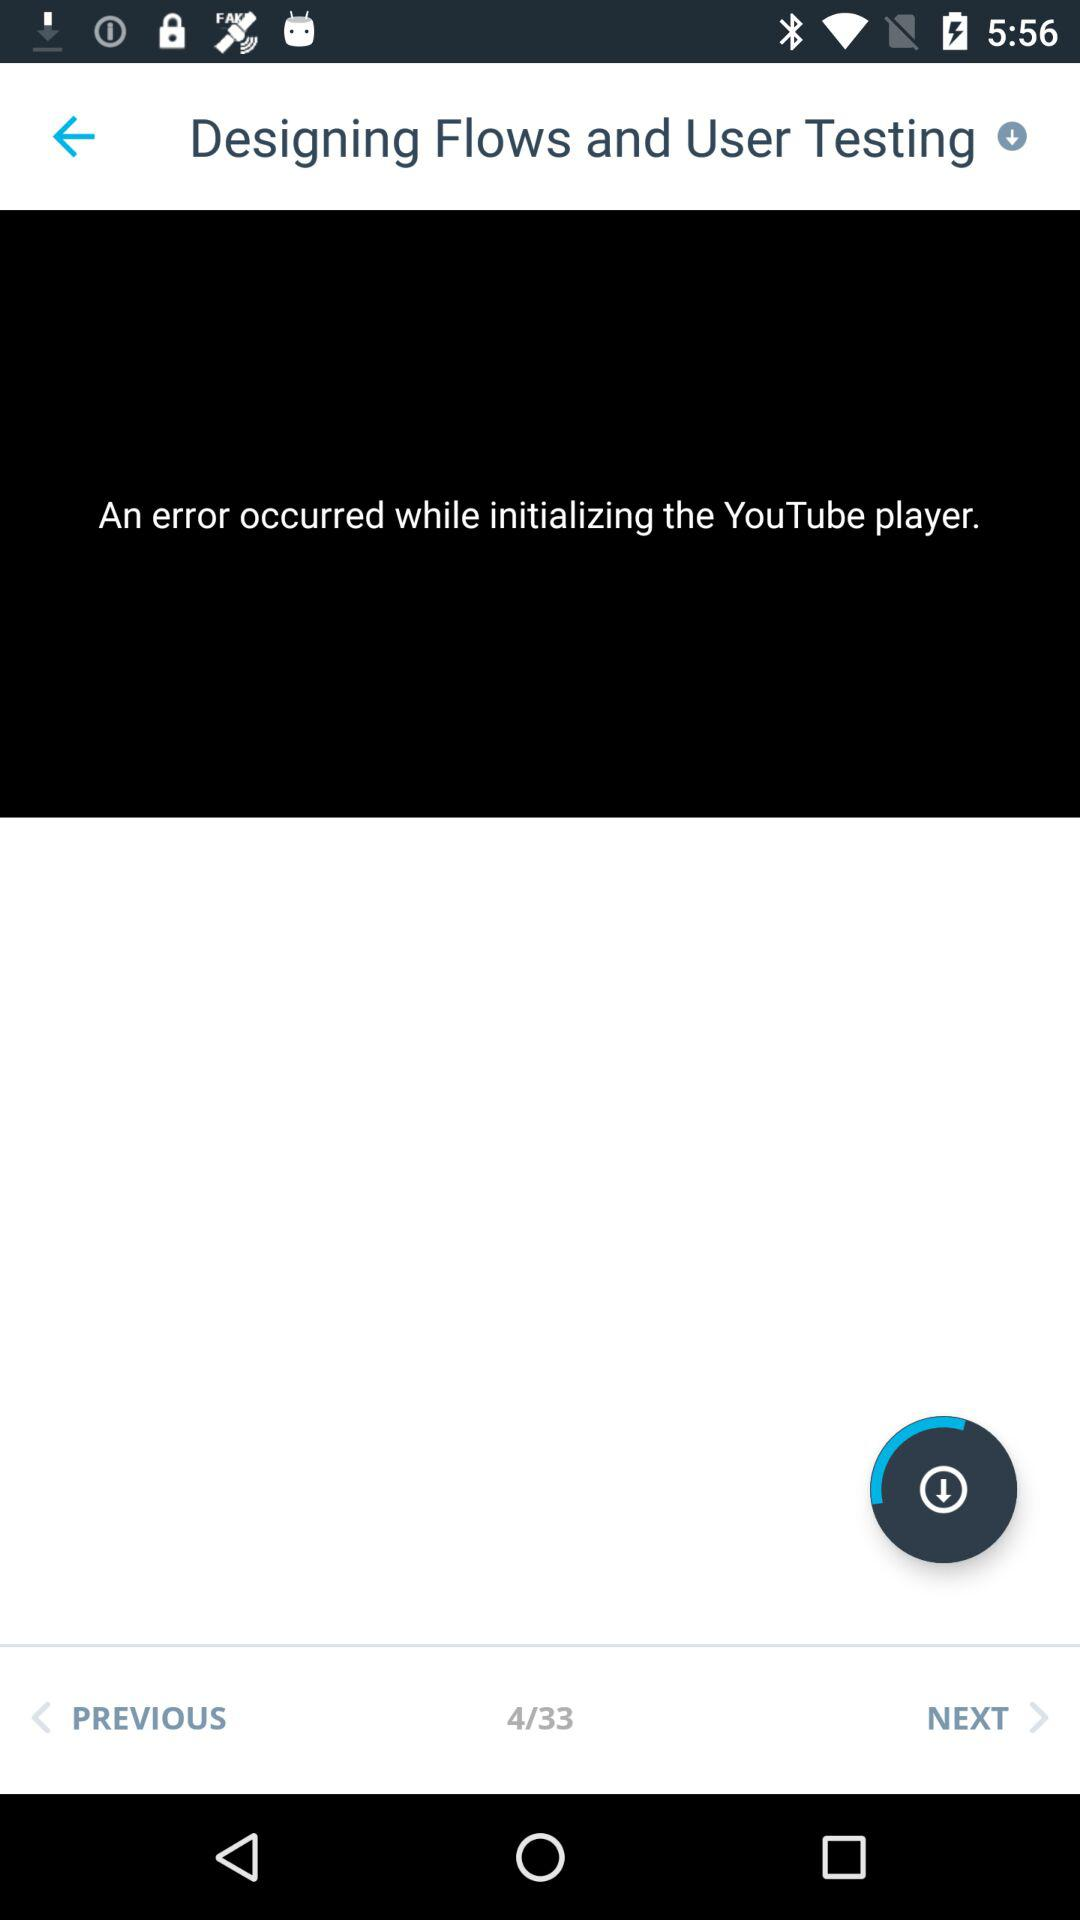How many total pages are there in "Designing Flows and User Testing"? There are a total of 33 pages. 